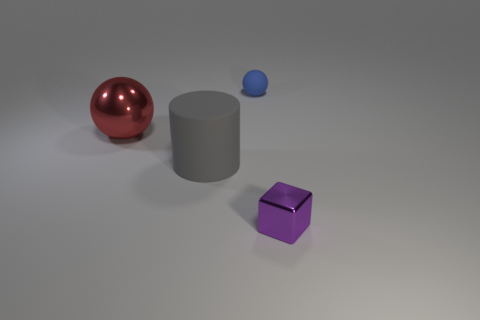Add 2 gray objects. How many objects exist? 6 Subtract all cubes. How many objects are left? 3 Add 2 small spheres. How many small spheres are left? 3 Add 1 gray cylinders. How many gray cylinders exist? 2 Subtract 0 purple spheres. How many objects are left? 4 Subtract all yellow cubes. Subtract all metal things. How many objects are left? 2 